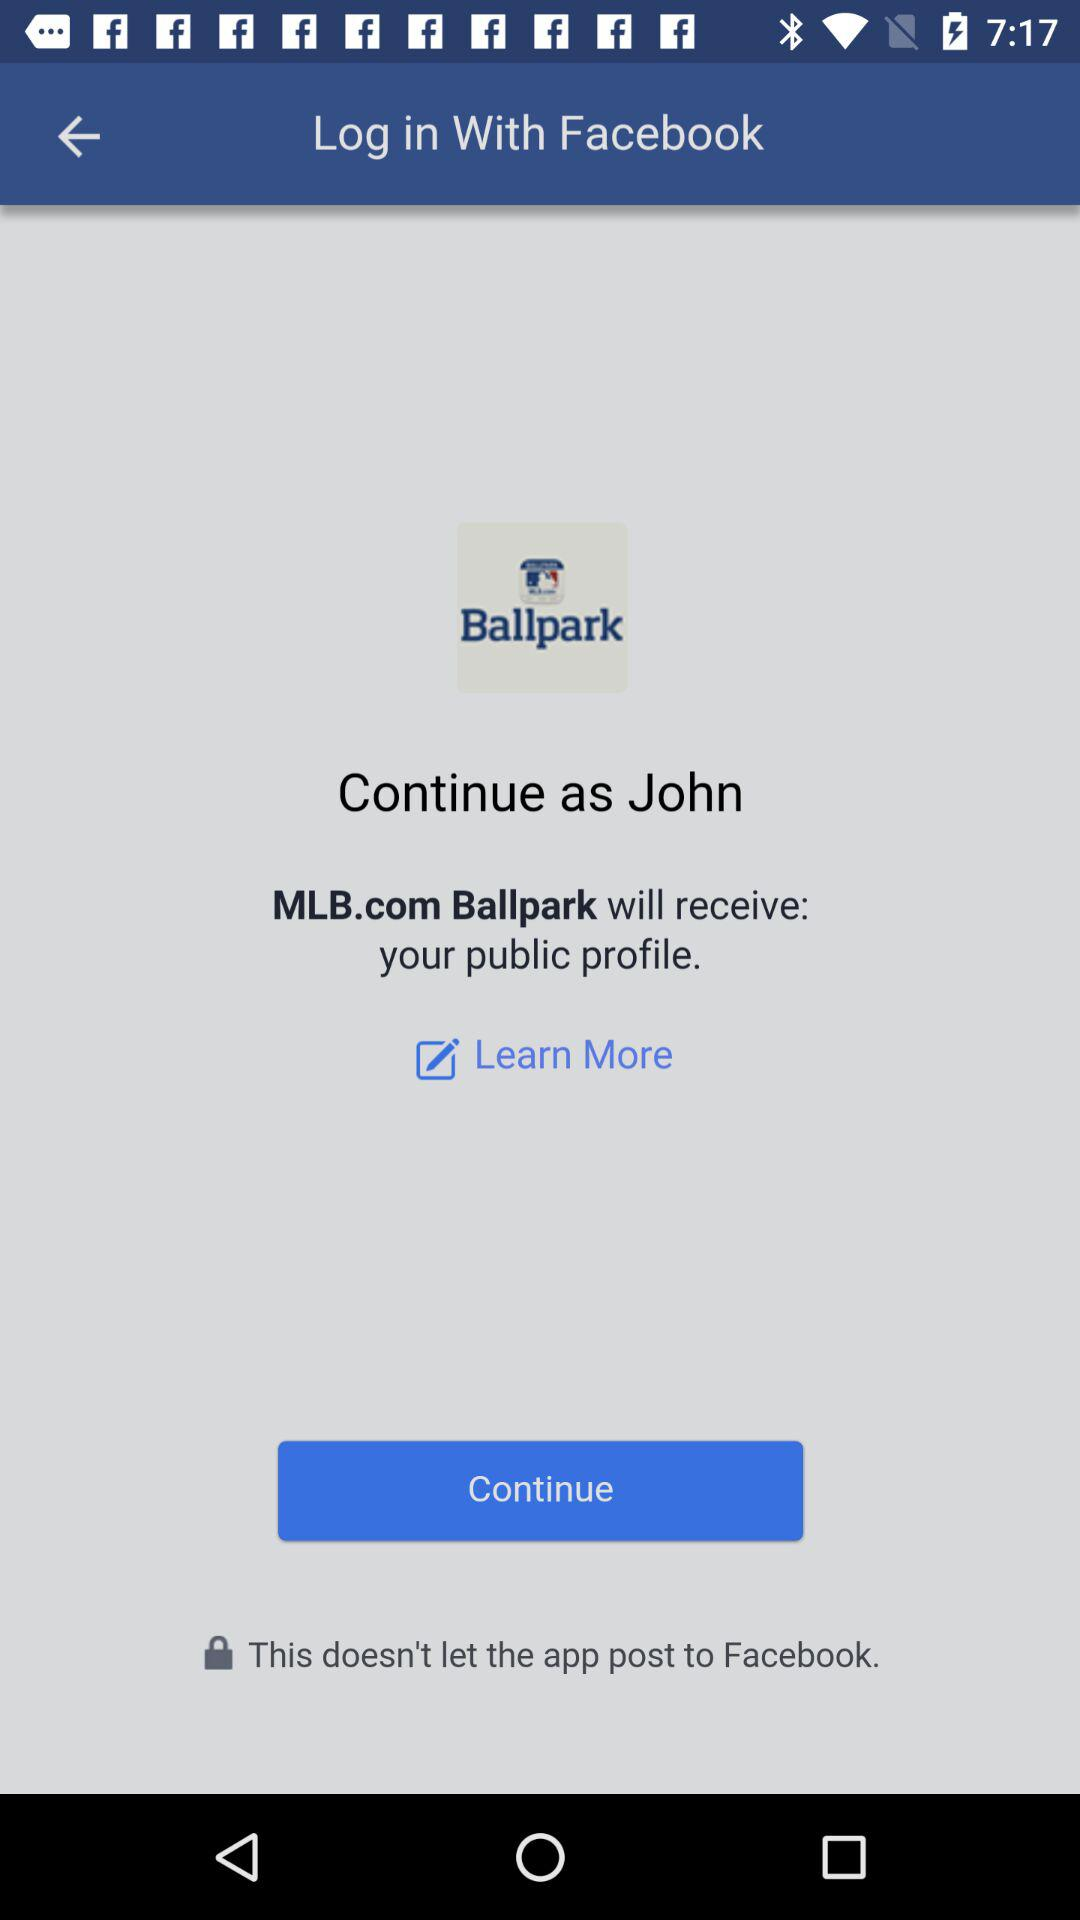What is the login name? The login name is "John". 